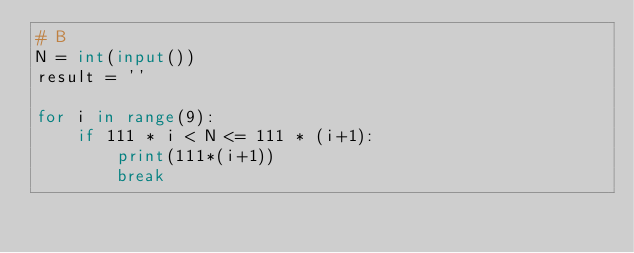<code> <loc_0><loc_0><loc_500><loc_500><_Python_># B
N = int(input())
result = ''

for i in range(9):
    if 111 * i < N <= 111 * (i+1):
        print(111*(i+1))
        break</code> 